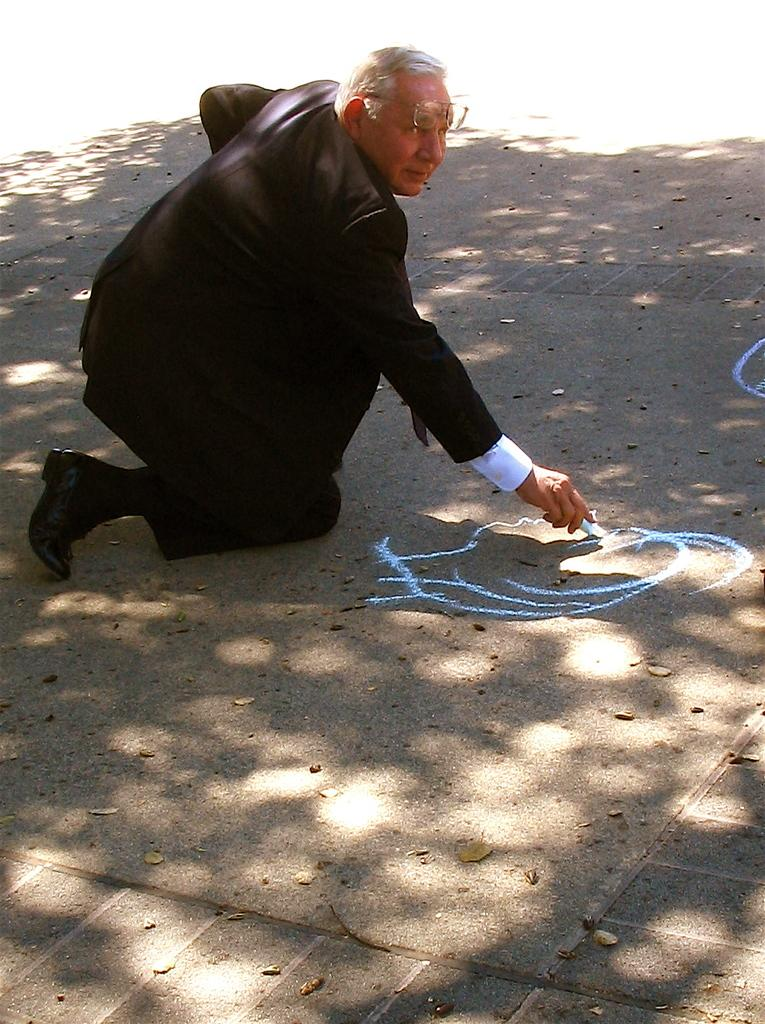What can be seen in the image related to a person? There is a person in the image. What accessories is the person wearing? The person is wearing glasses and a coat. What is the person holding in the image? The person is holding an object. What is present on the road in the image? There is rangoli on the road in the image. How many babies are visible in the image? There are no babies present in the image. What color are the person's eyes in the image? The person's eyes are not visible in the image, as they are wearing glasses. 